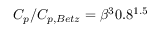Convert formula to latex. <formula><loc_0><loc_0><loc_500><loc_500>C _ { p } / C _ { p , B e t z } = \beta ^ { 3 } 0 . 8 ^ { 1 . 5 }</formula> 